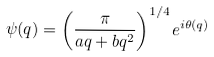<formula> <loc_0><loc_0><loc_500><loc_500>\psi ( q ) = \left ( \frac { \pi } { a q + b q ^ { 2 } } \right ) ^ { 1 / 4 } e ^ { i \theta ( q ) }</formula> 